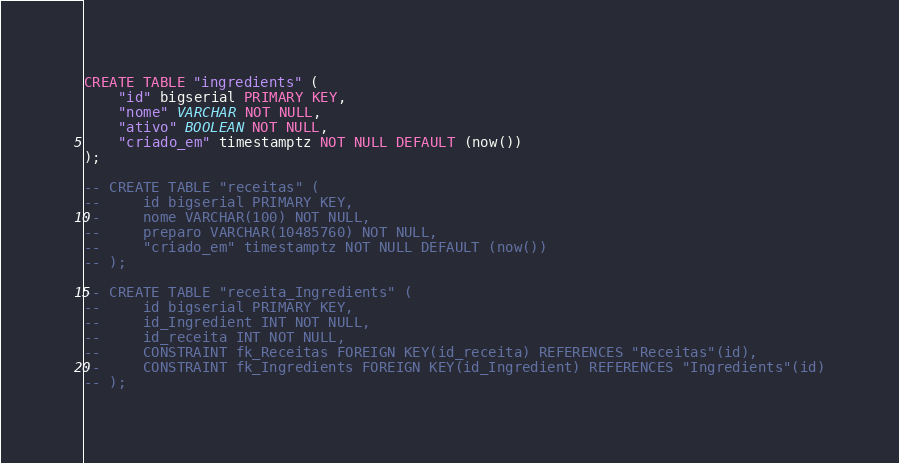<code> <loc_0><loc_0><loc_500><loc_500><_SQL_>CREATE TABLE "ingredients" (
    "id" bigserial PRIMARY KEY,
    "nome" VARCHAR NOT NULL,
    "ativo" BOOLEAN NOT NULL,
    "criado_em" timestamptz NOT NULL DEFAULT (now())
);

-- CREATE TABLE "receitas" (
--     id bigserial PRIMARY KEY,
--     nome VARCHAR(100) NOT NULL,
--     preparo VARCHAR(10485760) NOT NULL,
--     "criado_em" timestamptz NOT NULL DEFAULT (now())
-- );

-- CREATE TABLE "receita_Ingredients" (
--     id bigserial PRIMARY KEY,
--     id_Ingredient INT NOT NULL,
--     id_receita INT NOT NULL,
--     CONSTRAINT fk_Receitas FOREIGN KEY(id_receita) REFERENCES "Receitas"(id),
--     CONSTRAINT fk_Ingredients FOREIGN KEY(id_Ingredient) REFERENCES "Ingredients"(id)
-- );
</code> 